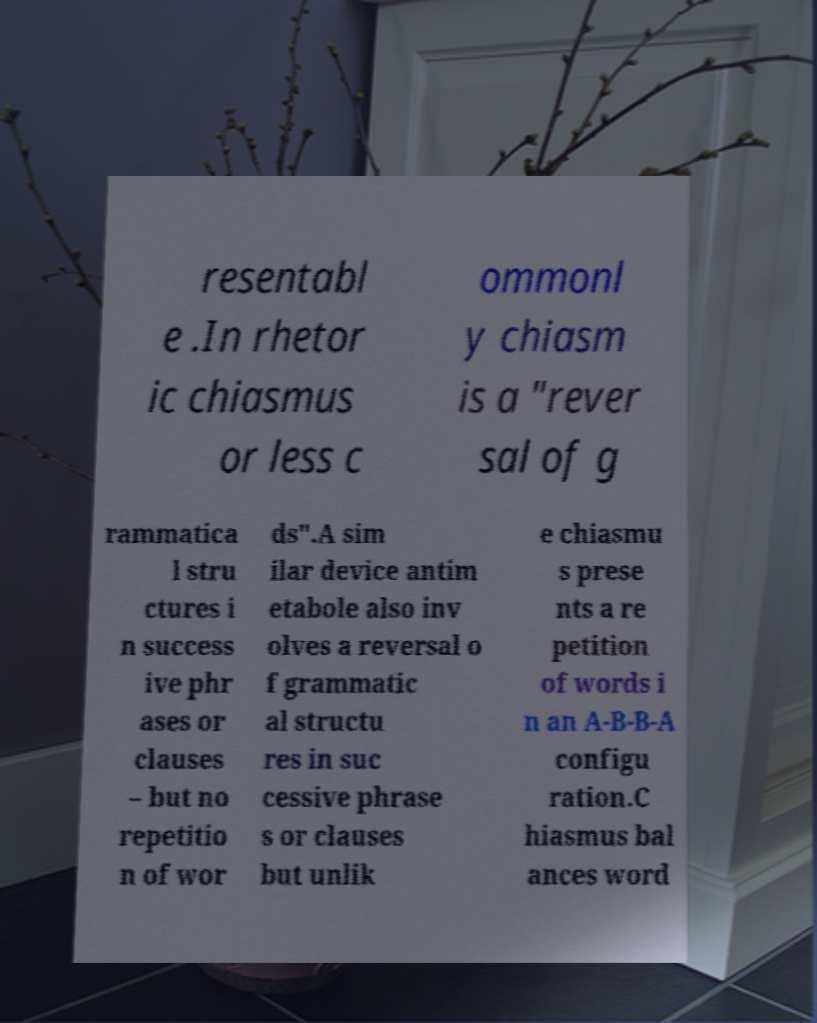What messages or text are displayed in this image? I need them in a readable, typed format. resentabl e .In rhetor ic chiasmus or less c ommonl y chiasm is a "rever sal of g rammatica l stru ctures i n success ive phr ases or clauses – but no repetitio n of wor ds".A sim ilar device antim etabole also inv olves a reversal o f grammatic al structu res in suc cessive phrase s or clauses but unlik e chiasmu s prese nts a re petition of words i n an A-B-B-A configu ration.C hiasmus bal ances word 